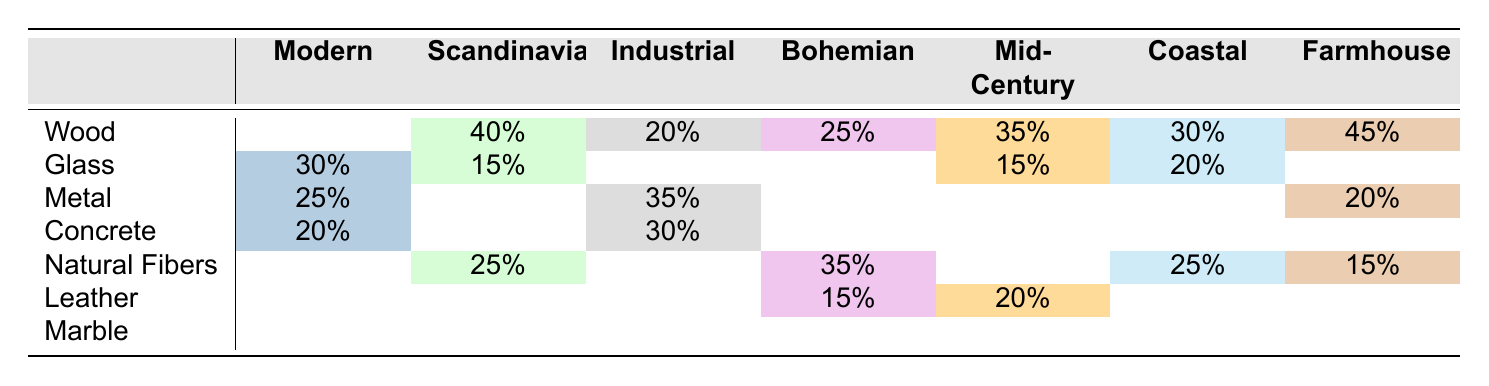What material is most commonly used in Farmhouse style? In the Farmhouse style, Wood is listed with a usage percentage of 45%, which is higher than the other materials in this style.
Answer: Wood Which style uses Metal the most? According to the table, the Industrial style has the highest percentage usage of Metal at 35%.
Answer: Industrial What is the total percentage of Natural Fibers used across all styles? To find this, we add the percentage of Natural Fibers used in Scandinavian (25%), Bohemian (35%), Coastal (25%), and Farmhouse (15%) styles: 25 + 35 + 25 + 15 = 100%.
Answer: 100% Is Leather used in the Modern style? The table shows that there is no percentage listed for Leather usage in the Modern style, indicating it is not used in that style.
Answer: No Which style features the highest percentage of Concrete? The table indicates that the Industrial style features the highest usage of Concrete at 30%.
Answer: Industrial What are the percentages of Wood usage across all styles? The percentages of Wood are: Modern (0%), Scandinavian (40%), Industrial (20%), Bohemian (25%), Mid-Century (35%), Coastal (30%), and Farmhouse (45%).
Answer: 0%, 40%, 20%, 25%, 35%, 30%, 45% Which material is used in both Bohemian and Coastal styles? The material Natural Fibers is used in both the Bohemian (35%) and Coastal (25%) styles.
Answer: Natural Fibers If we exclude the styles with no usage of Marble, what is the average percentage of Marble usage across the remaining styles? The table shows that Marble is not listed for any style, meaning its usage is 0%. Thus, the average is 0%.
Answer: 0% What is the difference in Wood usage between Farmhouse and Scandinavian styles? The percentage of Wood usage in Farmhouse is 45%, and in Scandinavian, it is 40%. The difference is 45 - 40 = 5%.
Answer: 5% Which style has the least variety in materials shown in the table? By analyzing the materials listed for each style, the Modern style only shows usage for Glass, Metal, and Concrete, totaling three materials used, which is less than the others.
Answer: Modern 